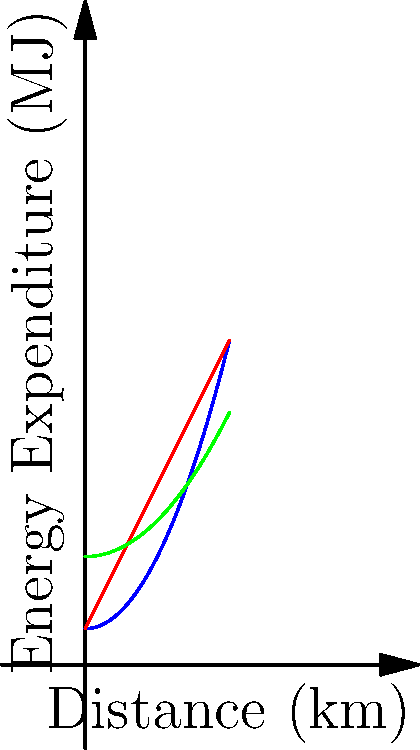The graph shows the energy expenditure of cows grazing on different terrains. If a cow travels 3 km on each terrain, calculate the difference in energy expenditure (in MJ) between grazing on hilly terrain versus flat terrain. To solve this problem, we need to follow these steps:

1. Identify the functions for hilly and flat terrains:
   Hilly: $f(x) = 0.5x^2 + 1$
   Flat: $g(x) = 2x + 1$

2. Calculate the energy expenditure for hilly terrain at 3 km:
   $f(3) = 0.5(3^2) + 1 = 0.5(9) + 1 = 4.5 + 1 = 5.5$ MJ

3. Calculate the energy expenditure for flat terrain at 3 km:
   $g(3) = 2(3) + 1 = 6 + 1 = 7$ MJ

4. Calculate the difference in energy expenditure:
   Difference = Flat terrain - Hilly terrain
   $7 - 5.5 = 1.5$ MJ

Therefore, the difference in energy expenditure between grazing on hilly terrain versus flat terrain over a distance of 3 km is 1.5 MJ.
Answer: 1.5 MJ 